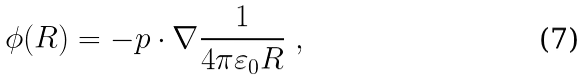Convert formula to latex. <formula><loc_0><loc_0><loc_500><loc_500>\phi ( R ) = - p \cdot \nabla { \frac { 1 } { 4 \pi \varepsilon _ { 0 } R } } \ ,</formula> 